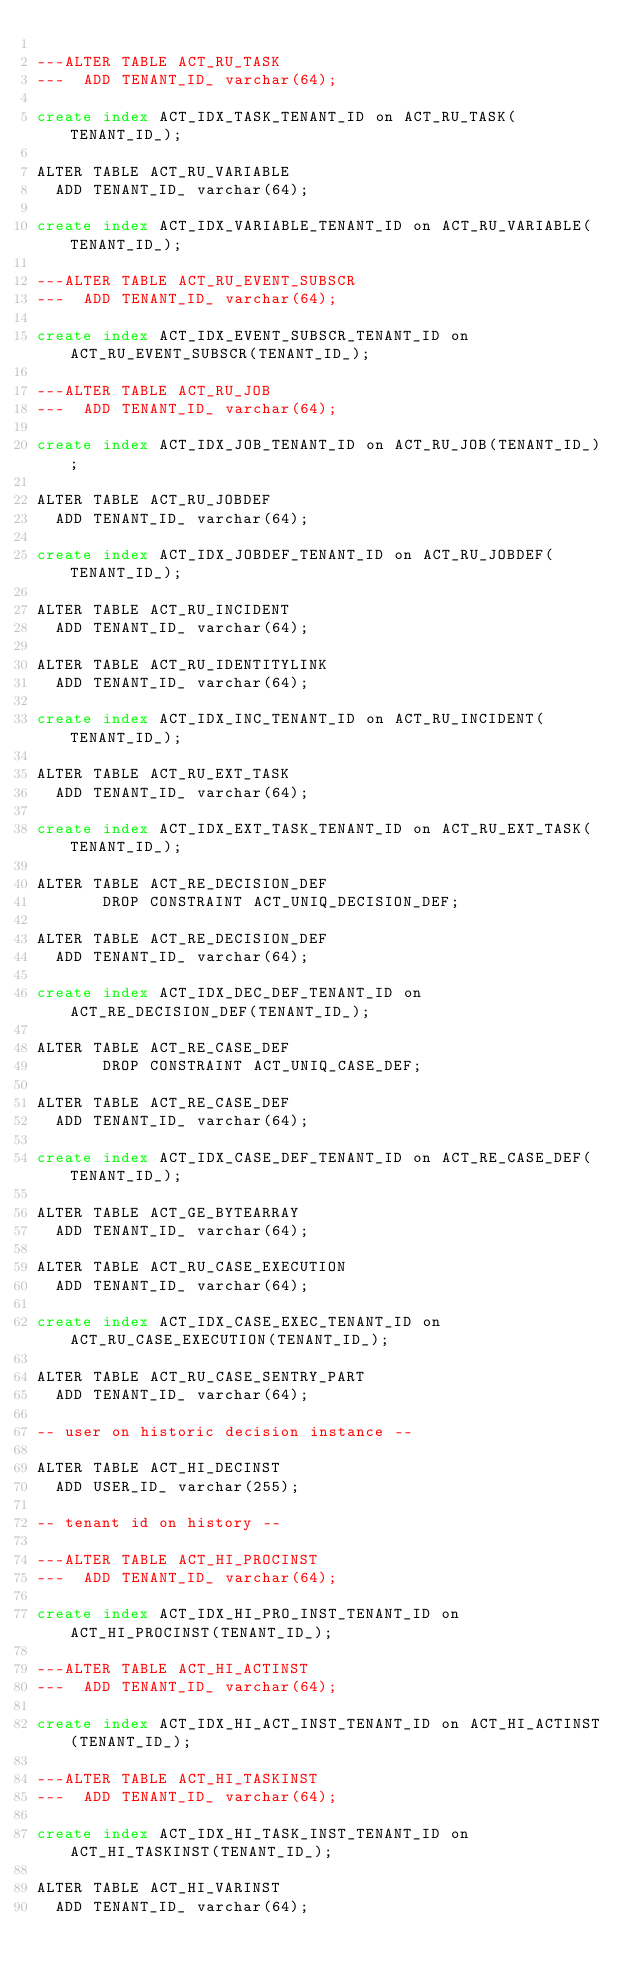Convert code to text. <code><loc_0><loc_0><loc_500><loc_500><_SQL_>
---ALTER TABLE ACT_RU_TASK
---  ADD TENANT_ID_ varchar(64);

create index ACT_IDX_TASK_TENANT_ID on ACT_RU_TASK(TENANT_ID_);

ALTER TABLE ACT_RU_VARIABLE
  ADD TENANT_ID_ varchar(64);

create index ACT_IDX_VARIABLE_TENANT_ID on ACT_RU_VARIABLE(TENANT_ID_);

---ALTER TABLE ACT_RU_EVENT_SUBSCR
---  ADD TENANT_ID_ varchar(64);

create index ACT_IDX_EVENT_SUBSCR_TENANT_ID on ACT_RU_EVENT_SUBSCR(TENANT_ID_);

---ALTER TABLE ACT_RU_JOB
---  ADD TENANT_ID_ varchar(64);

create index ACT_IDX_JOB_TENANT_ID on ACT_RU_JOB(TENANT_ID_);

ALTER TABLE ACT_RU_JOBDEF
  ADD TENANT_ID_ varchar(64);

create index ACT_IDX_JOBDEF_TENANT_ID on ACT_RU_JOBDEF(TENANT_ID_);

ALTER TABLE ACT_RU_INCIDENT
  ADD TENANT_ID_ varchar(64);

ALTER TABLE ACT_RU_IDENTITYLINK
  ADD TENANT_ID_ varchar(64);

create index ACT_IDX_INC_TENANT_ID on ACT_RU_INCIDENT(TENANT_ID_);

ALTER TABLE ACT_RU_EXT_TASK
  ADD TENANT_ID_ varchar(64);

create index ACT_IDX_EXT_TASK_TENANT_ID on ACT_RU_EXT_TASK(TENANT_ID_);

ALTER TABLE ACT_RE_DECISION_DEF
       DROP CONSTRAINT ACT_UNIQ_DECISION_DEF;

ALTER TABLE ACT_RE_DECISION_DEF
  ADD TENANT_ID_ varchar(64);

create index ACT_IDX_DEC_DEF_TENANT_ID on ACT_RE_DECISION_DEF(TENANT_ID_);

ALTER TABLE ACT_RE_CASE_DEF
       DROP CONSTRAINT ACT_UNIQ_CASE_DEF;

ALTER TABLE ACT_RE_CASE_DEF
  ADD TENANT_ID_ varchar(64);

create index ACT_IDX_CASE_DEF_TENANT_ID on ACT_RE_CASE_DEF(TENANT_ID_);

ALTER TABLE ACT_GE_BYTEARRAY
  ADD TENANT_ID_ varchar(64);

ALTER TABLE ACT_RU_CASE_EXECUTION
  ADD TENANT_ID_ varchar(64);

create index ACT_IDX_CASE_EXEC_TENANT_ID on ACT_RU_CASE_EXECUTION(TENANT_ID_);

ALTER TABLE ACT_RU_CASE_SENTRY_PART
  ADD TENANT_ID_ varchar(64);

-- user on historic decision instance --

ALTER TABLE ACT_HI_DECINST
  ADD USER_ID_ varchar(255);

-- tenant id on history --

---ALTER TABLE ACT_HI_PROCINST
---  ADD TENANT_ID_ varchar(64);

create index ACT_IDX_HI_PRO_INST_TENANT_ID on ACT_HI_PROCINST(TENANT_ID_);

---ALTER TABLE ACT_HI_ACTINST
---  ADD TENANT_ID_ varchar(64);

create index ACT_IDX_HI_ACT_INST_TENANT_ID on ACT_HI_ACTINST(TENANT_ID_);

---ALTER TABLE ACT_HI_TASKINST
---  ADD TENANT_ID_ varchar(64);

create index ACT_IDX_HI_TASK_INST_TENANT_ID on ACT_HI_TASKINST(TENANT_ID_);

ALTER TABLE ACT_HI_VARINST
  ADD TENANT_ID_ varchar(64);
</code> 